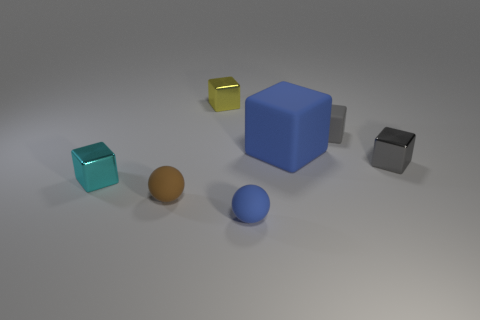There is another thing that is the same color as the big thing; what is its shape?
Ensure brevity in your answer.  Sphere. What size is the other thing that is the same color as the large object?
Keep it short and to the point. Small. How many other things are the same shape as the gray shiny thing?
Your answer should be compact. 4. What material is the block that is to the left of the small matte sphere left of the small yellow shiny block made of?
Offer a very short reply. Metal. Are there any gray matte things behind the tiny yellow metal thing?
Your response must be concise. No. Is the size of the yellow shiny thing the same as the rubber cube that is in front of the tiny matte block?
Offer a terse response. No. There is a gray metallic object that is the same shape as the tiny yellow metal object; what is its size?
Provide a succinct answer. Small. Do the blue object that is behind the cyan shiny object and the matte ball that is left of the yellow metal thing have the same size?
Your answer should be very brief. No. How many large things are either purple matte blocks or blue cubes?
Your response must be concise. 1. What number of objects are both on the right side of the yellow object and to the left of the small brown matte sphere?
Keep it short and to the point. 0. 